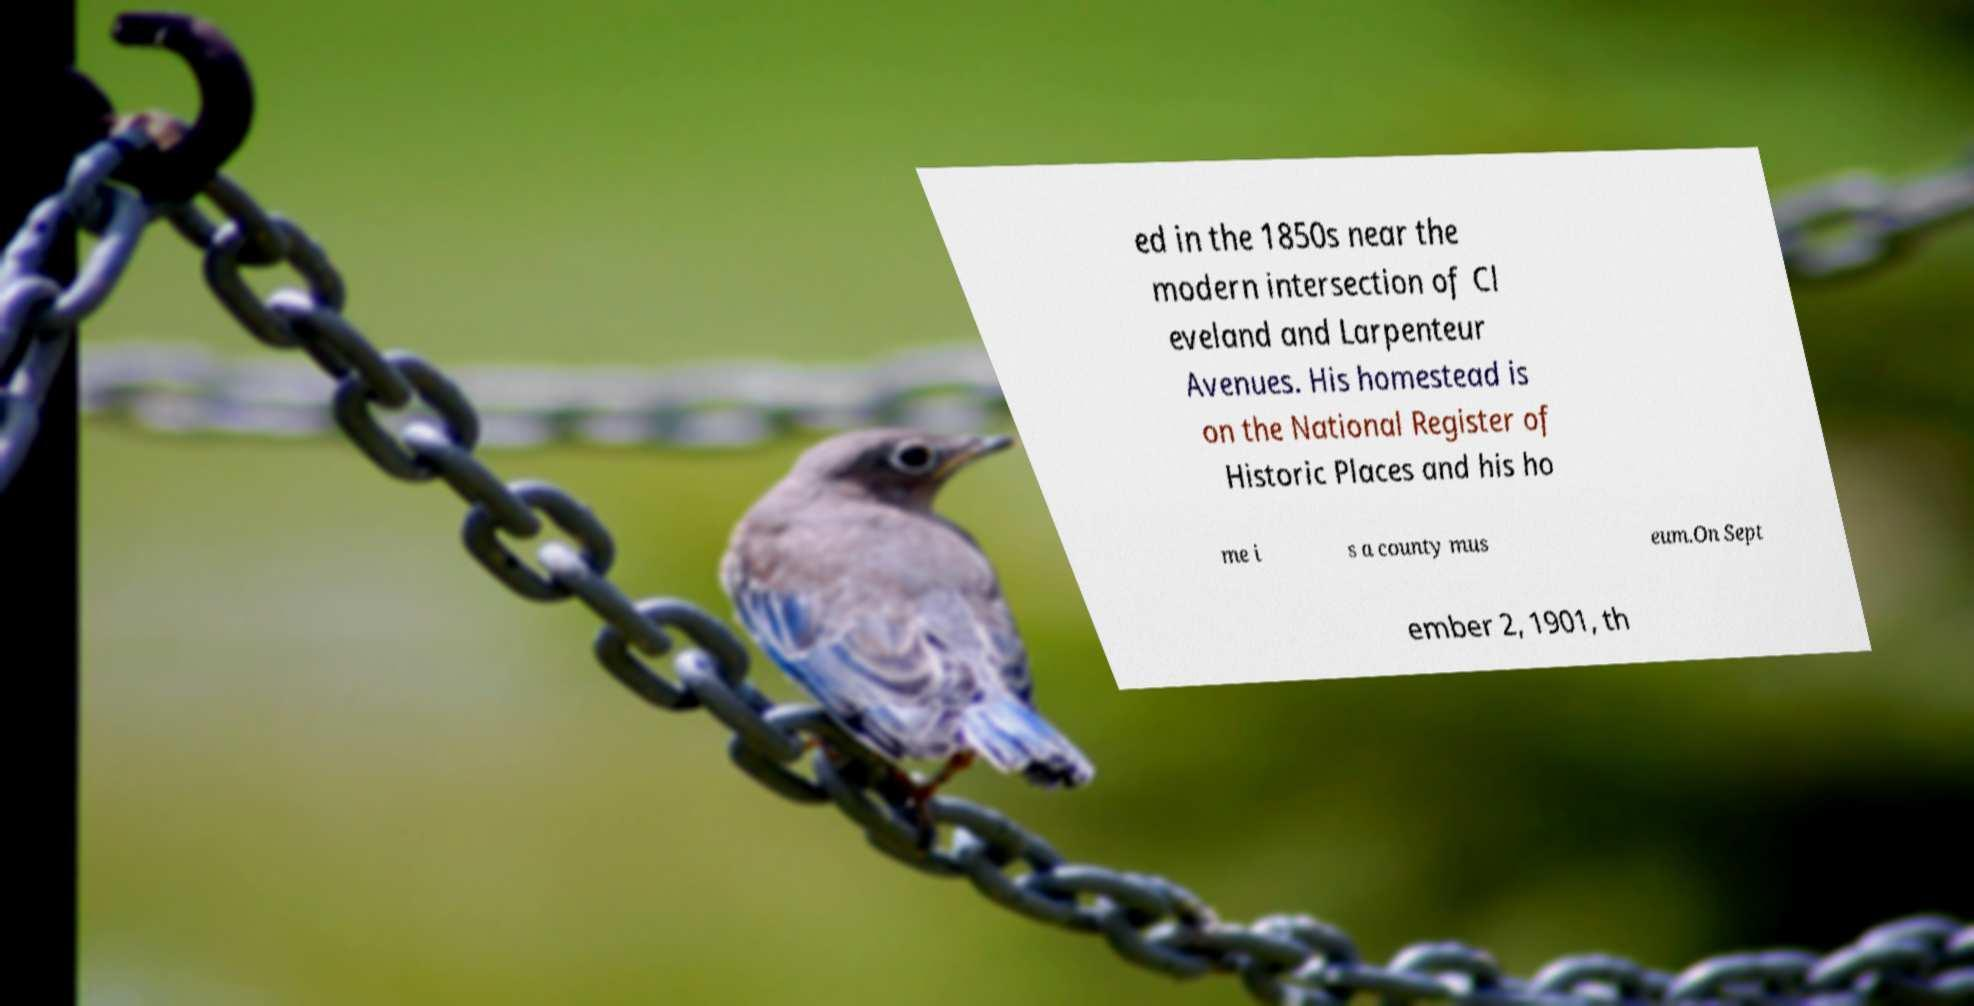Could you assist in decoding the text presented in this image and type it out clearly? ed in the 1850s near the modern intersection of Cl eveland and Larpenteur Avenues. His homestead is on the National Register of Historic Places and his ho me i s a county mus eum.On Sept ember 2, 1901, th 